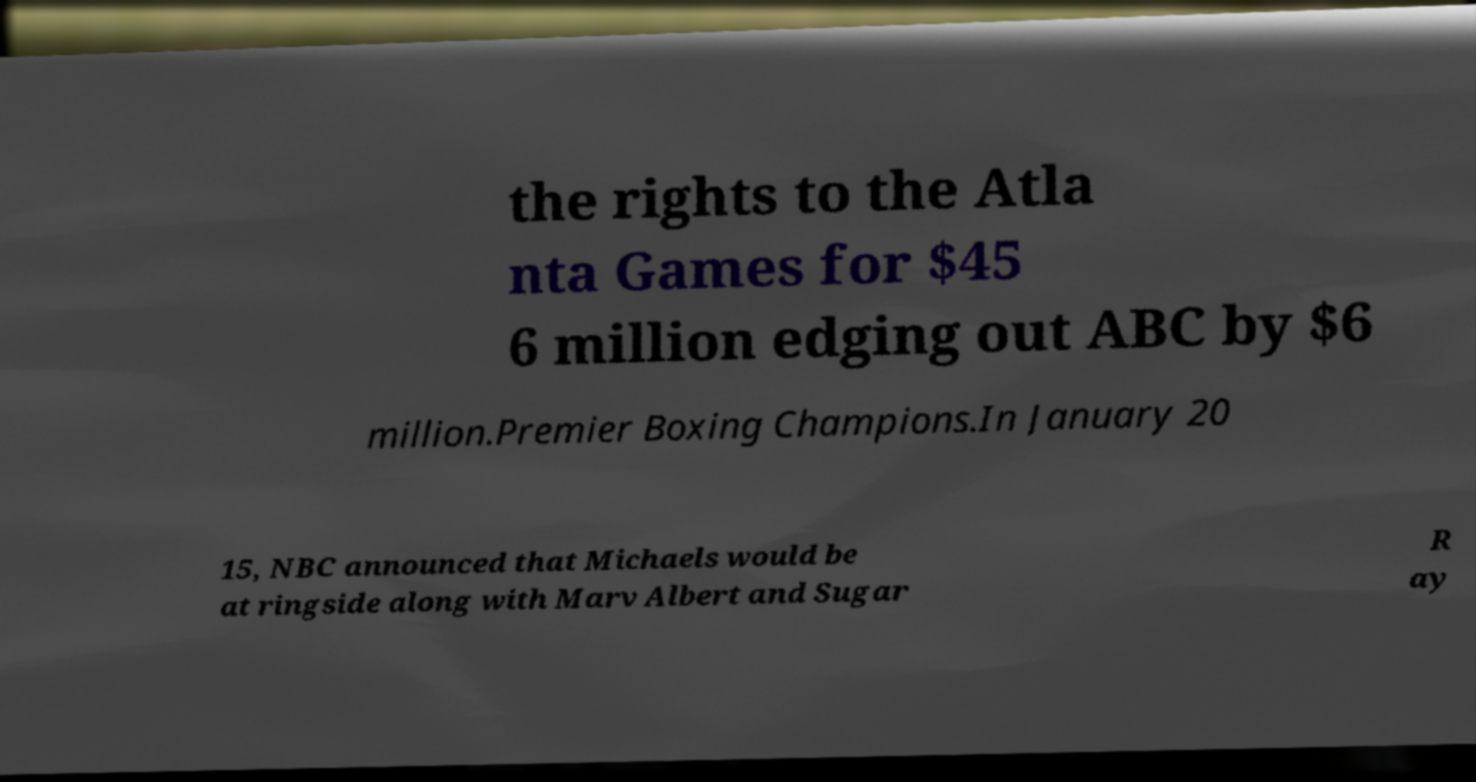What messages or text are displayed in this image? I need them in a readable, typed format. the rights to the Atla nta Games for $45 6 million edging out ABC by $6 million.Premier Boxing Champions.In January 20 15, NBC announced that Michaels would be at ringside along with Marv Albert and Sugar R ay 